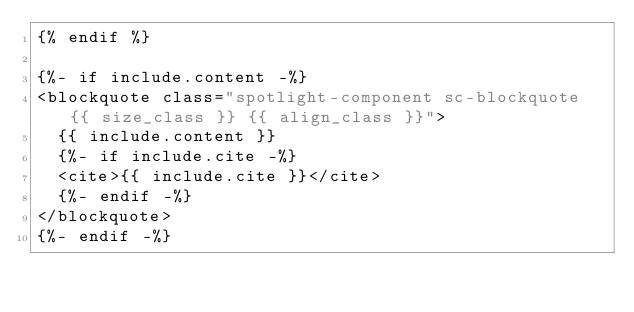Convert code to text. <code><loc_0><loc_0><loc_500><loc_500><_HTML_>{% endif %}

{%- if include.content -%}
<blockquote class="spotlight-component sc-blockquote {{ size_class }} {{ align_class }}">
  {{ include.content }}
  {%- if include.cite -%}
  <cite>{{ include.cite }}</cite>
  {%- endif -%}
</blockquote>
{%- endif -%}
</code> 